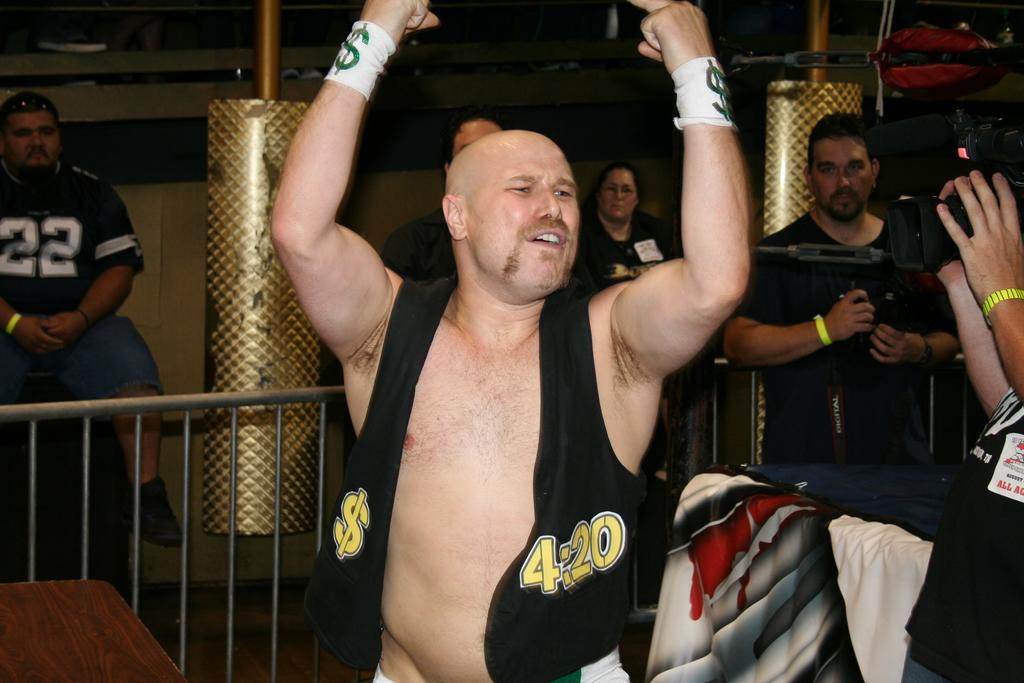<image>
Write a terse but informative summary of the picture. A wrestler with an open vest that says 4:20 on it. 